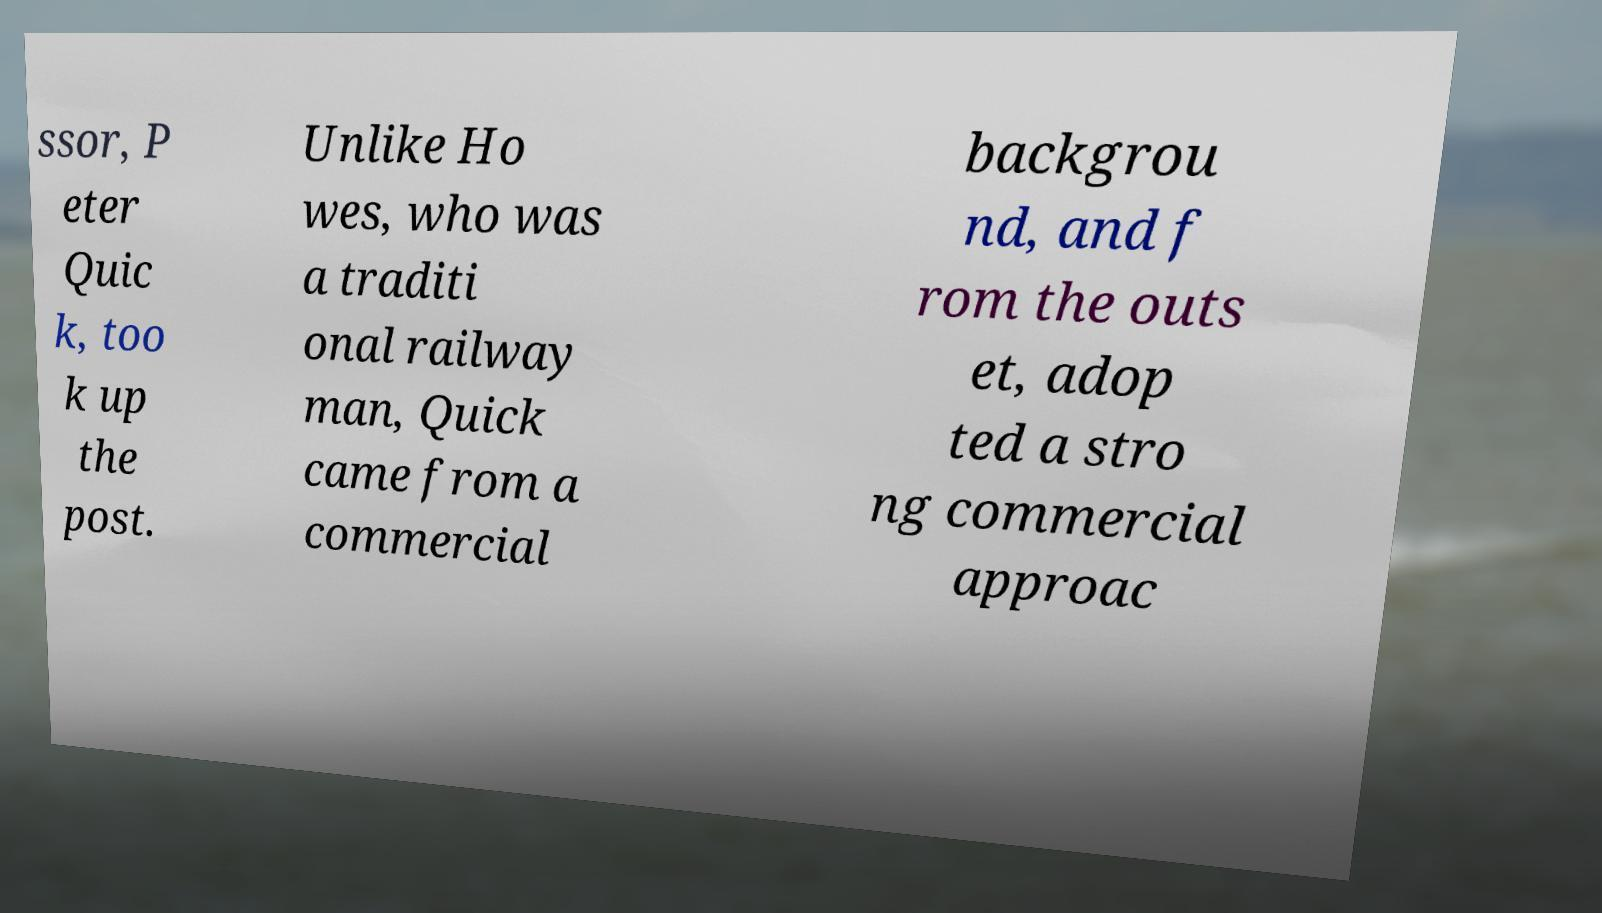For documentation purposes, I need the text within this image transcribed. Could you provide that? ssor, P eter Quic k, too k up the post. Unlike Ho wes, who was a traditi onal railway man, Quick came from a commercial backgrou nd, and f rom the outs et, adop ted a stro ng commercial approac 